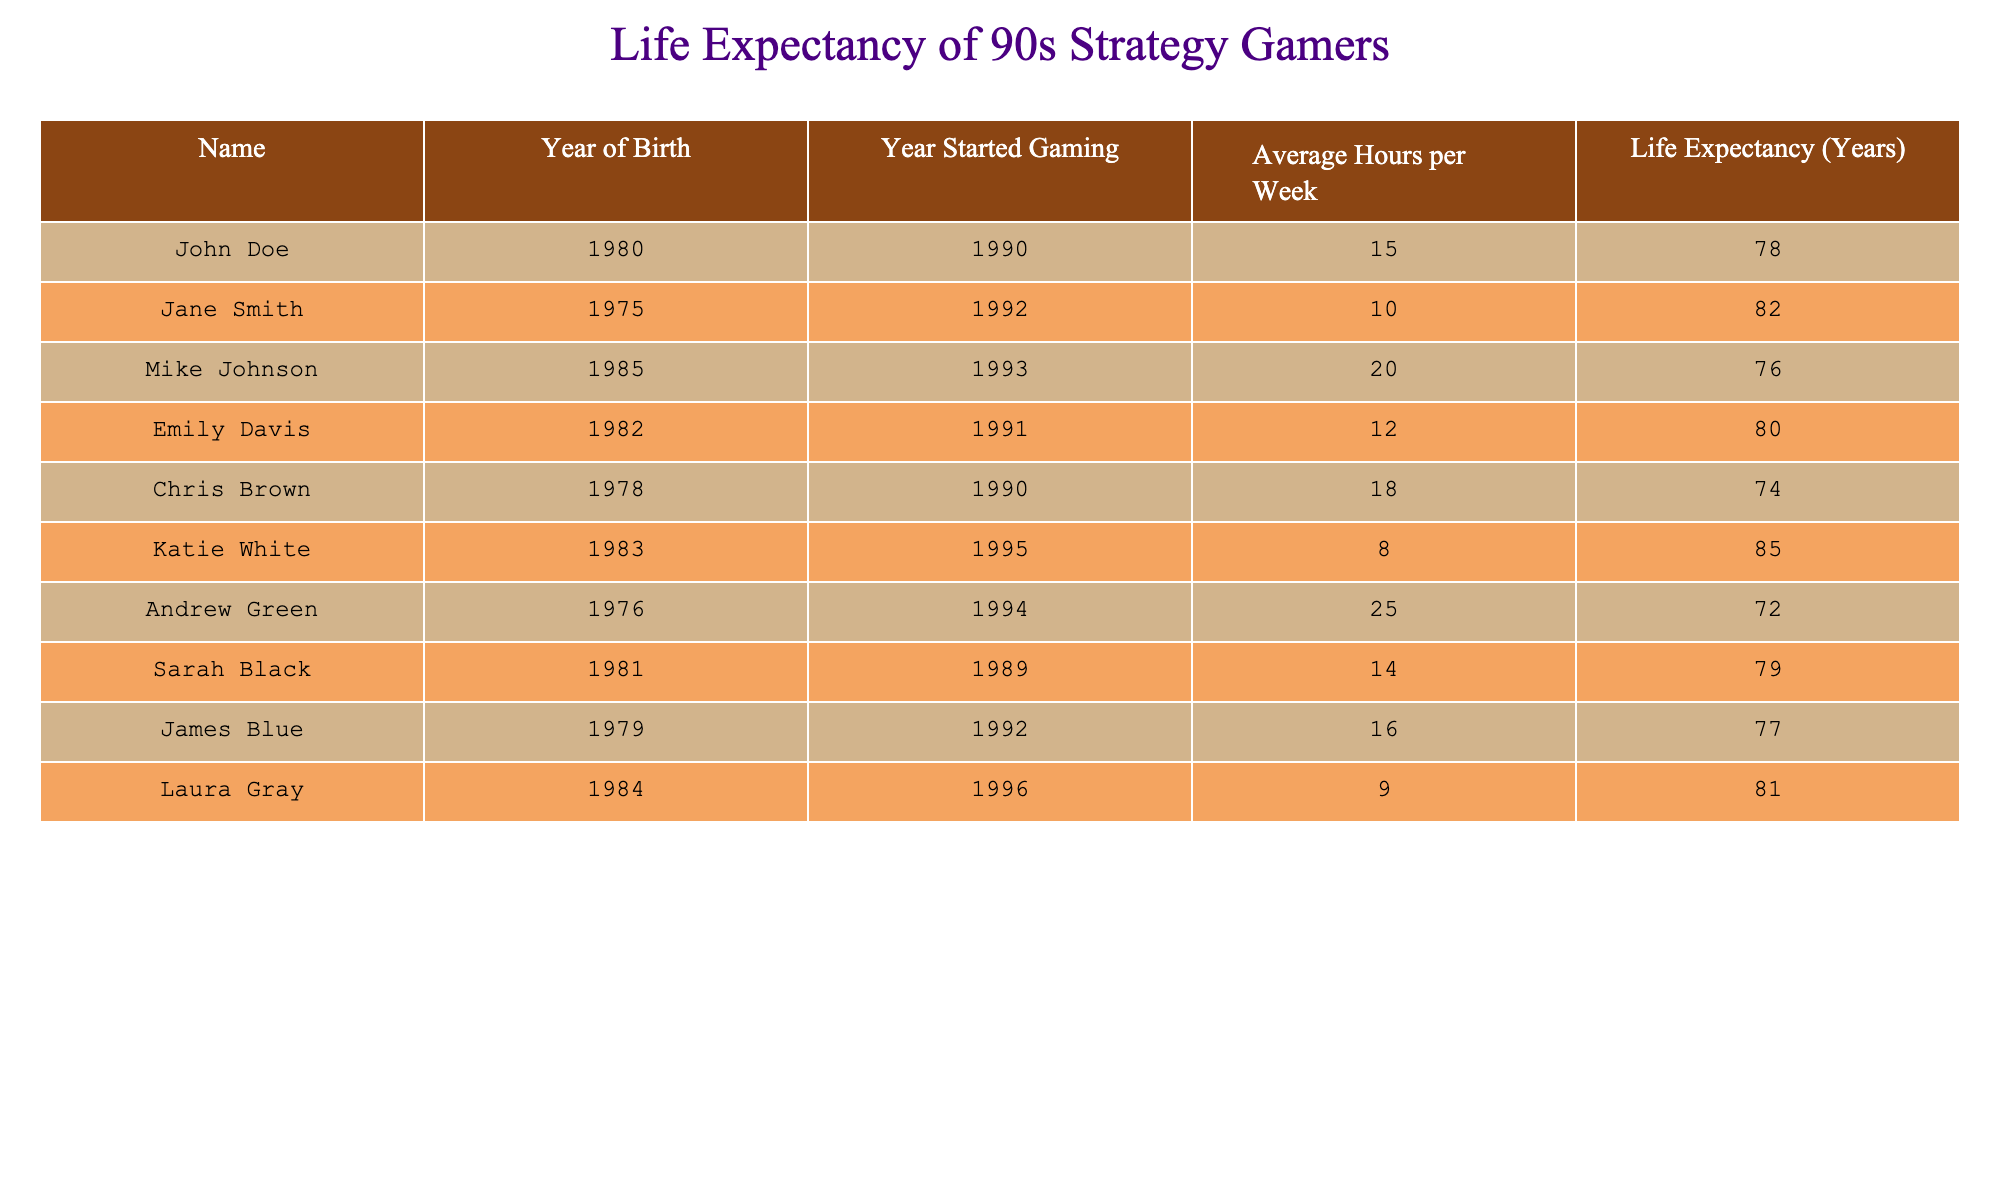What is the life expectancy of Jane Smith? Referring directly to the table, the life expectancy listed for Jane Smith is 82 years.
Answer: 82 Who had the lowest life expectancy among the gamers listed? By examining the life expectancy values in the table, Andrew Green has the lowest life expectancy at 72 years.
Answer: Andrew Green What is the average life expectancy of the gamers whose average gaming hours per week is greater than 15? First, we identify the gamers with average hours more than 15: Mike Johnson (76), Chris Brown (74), and Andrew Green (72). Then, we calculate the average: (76 + 74 + 72) / 3 = 74.
Answer: 74 Did any gamer start gaming in the year 1990 have a life expectancy above 75 years? Looking at the table, both John Doe and Chris Brown started gaming in 1990. John Doe's life expectancy is 78, which is above 75, while Chris Brown's is 74, which is not. Therefore, yes, John Doe meets this criterion.
Answer: Yes What is the life expectancy difference between the oldest and youngest gamers listed in the table? The oldest gamer is Katie White (born in 1983) with a life expectancy of 85 years, and the youngest is Mike Johnson (born in 1985) with a life expectancy of 76 years. The difference is 85 - 76 = 9 years.
Answer: 9 